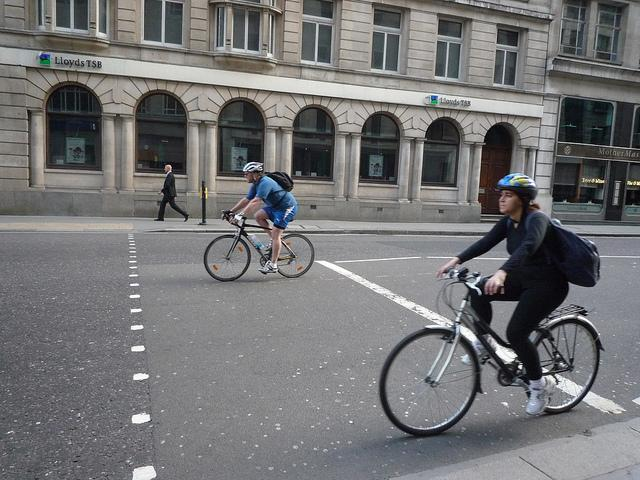When did two companies merge into this one bank? Please explain your reasoning. 1995. Lloyds s&b was a merger from the year 1995. 